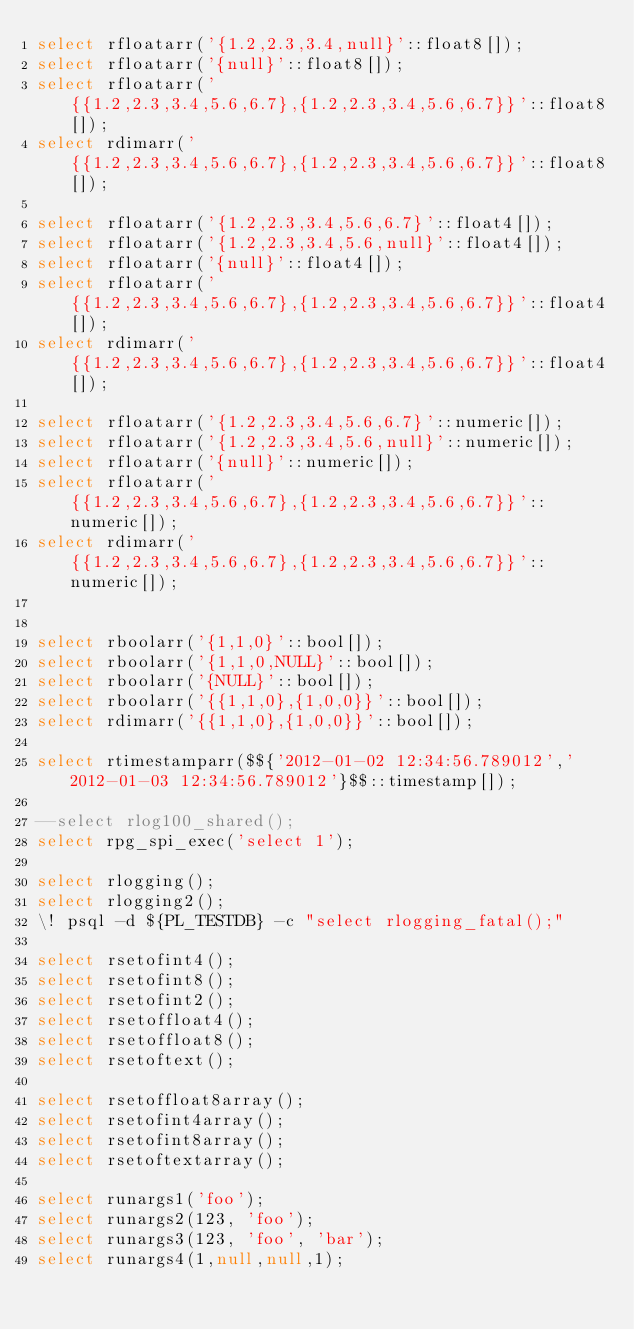Convert code to text. <code><loc_0><loc_0><loc_500><loc_500><_SQL_>select rfloatarr('{1.2,2.3,3.4,null}'::float8[]);
select rfloatarr('{null}'::float8[]);
select rfloatarr('{{1.2,2.3,3.4,5.6,6.7},{1.2,2.3,3.4,5.6,6.7}}'::float8[]);
select rdimarr('{{1.2,2.3,3.4,5.6,6.7},{1.2,2.3,3.4,5.6,6.7}}'::float8[]);

select rfloatarr('{1.2,2.3,3.4,5.6,6.7}'::float4[]);
select rfloatarr('{1.2,2.3,3.4,5.6,null}'::float4[]);
select rfloatarr('{null}'::float4[]);
select rfloatarr('{{1.2,2.3,3.4,5.6,6.7},{1.2,2.3,3.4,5.6,6.7}}'::float4[]);
select rdimarr('{{1.2,2.3,3.4,5.6,6.7},{1.2,2.3,3.4,5.6,6.7}}'::float4[]);

select rfloatarr('{1.2,2.3,3.4,5.6,6.7}'::numeric[]);
select rfloatarr('{1.2,2.3,3.4,5.6,null}'::numeric[]);
select rfloatarr('{null}'::numeric[]);
select rfloatarr('{{1.2,2.3,3.4,5.6,6.7},{1.2,2.3,3.4,5.6,6.7}}'::numeric[]);
select rdimarr('{{1.2,2.3,3.4,5.6,6.7},{1.2,2.3,3.4,5.6,6.7}}'::numeric[]);


select rboolarr('{1,1,0}'::bool[]);
select rboolarr('{1,1,0,NULL}'::bool[]);
select rboolarr('{NULL}'::bool[]);
select rboolarr('{{1,1,0},{1,0,0}}'::bool[]);
select rdimarr('{{1,1,0},{1,0,0}}'::bool[]);

select rtimestamparr($${'2012-01-02 12:34:56.789012','2012-01-03 12:34:56.789012'}$$::timestamp[]);

--select rlog100_shared();
select rpg_spi_exec('select 1');

select rlogging();
select rlogging2();
\! psql -d ${PL_TESTDB} -c "select rlogging_fatal();"

select rsetofint4();
select rsetofint8();
select rsetofint2();
select rsetoffloat4();
select rsetoffloat8();
select rsetoftext();

select rsetoffloat8array();
select rsetofint4array();
select rsetofint8array();
select rsetoftextarray();

select runargs1('foo');
select runargs2(123, 'foo');
select runargs3(123, 'foo', 'bar');
select runargs4(1,null,null,1);
</code> 